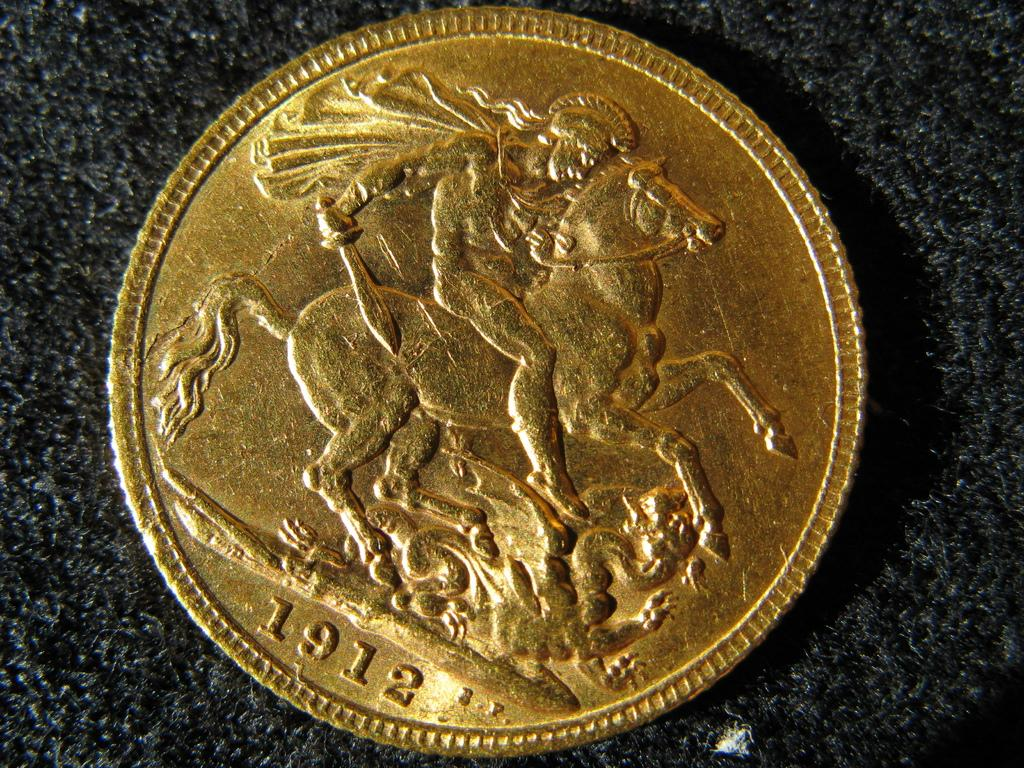<image>
Share a concise interpretation of the image provided. A coin fro 1912 shows a man on a horse. 